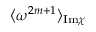Convert formula to latex. <formula><loc_0><loc_0><loc_500><loc_500>\langle \omega ^ { 2 m + 1 } \rangle _ { I m \chi }</formula> 